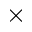Convert formula to latex. <formula><loc_0><loc_0><loc_500><loc_500>\times</formula> 